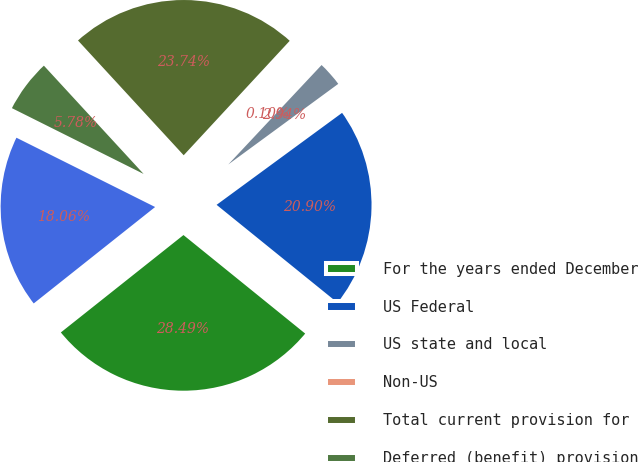Convert chart. <chart><loc_0><loc_0><loc_500><loc_500><pie_chart><fcel>For the years ended December<fcel>US Federal<fcel>US state and local<fcel>Non-US<fcel>Total current provision for<fcel>Deferred (benefit) provision<fcel>Total provision for income<nl><fcel>28.49%<fcel>20.9%<fcel>2.94%<fcel>0.1%<fcel>23.74%<fcel>5.78%<fcel>18.06%<nl></chart> 